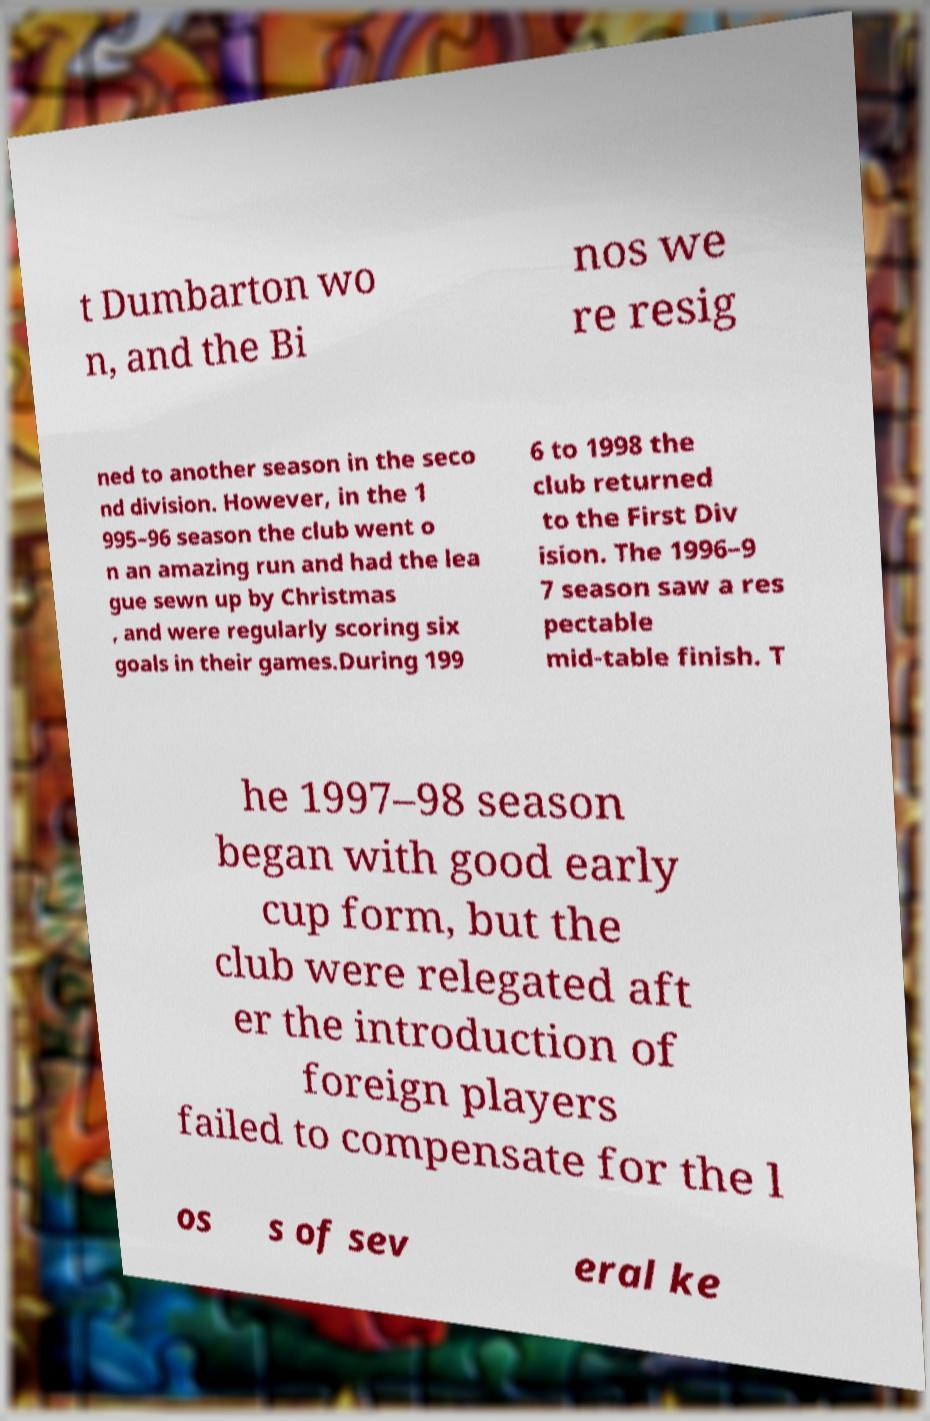Please identify and transcribe the text found in this image. t Dumbarton wo n, and the Bi nos we re resig ned to another season in the seco nd division. However, in the 1 995–96 season the club went o n an amazing run and had the lea gue sewn up by Christmas , and were regularly scoring six goals in their games.During 199 6 to 1998 the club returned to the First Div ision. The 1996–9 7 season saw a res pectable mid-table finish. T he 1997–98 season began with good early cup form, but the club were relegated aft er the introduction of foreign players failed to compensate for the l os s of sev eral ke 